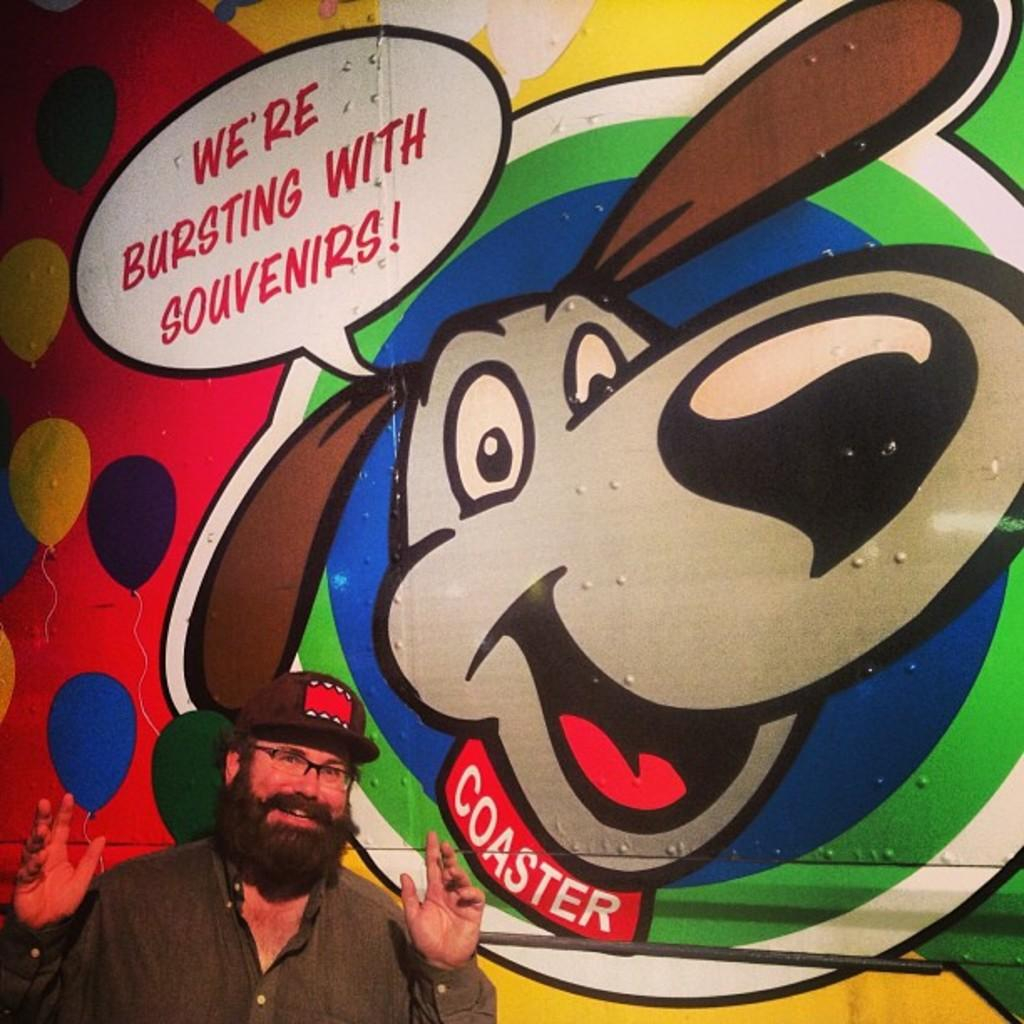What is the main subject of the image? There is a person in the image. What is the person wearing on their head? The person is wearing a hat. What is the person's posture in the image? The person is standing. What can be seen in the background of the image? There is a huge wall in the background of the image. What is depicted on the wall? There is a colorful painting on the wall. What type of clouds can be seen in the painting on the wall? There are no clouds visible in the painting on the wall; it features a colorful design. How many sons does the person in the image have? There is no information about the person's family in the image, so it cannot be determined if they have any sons. 